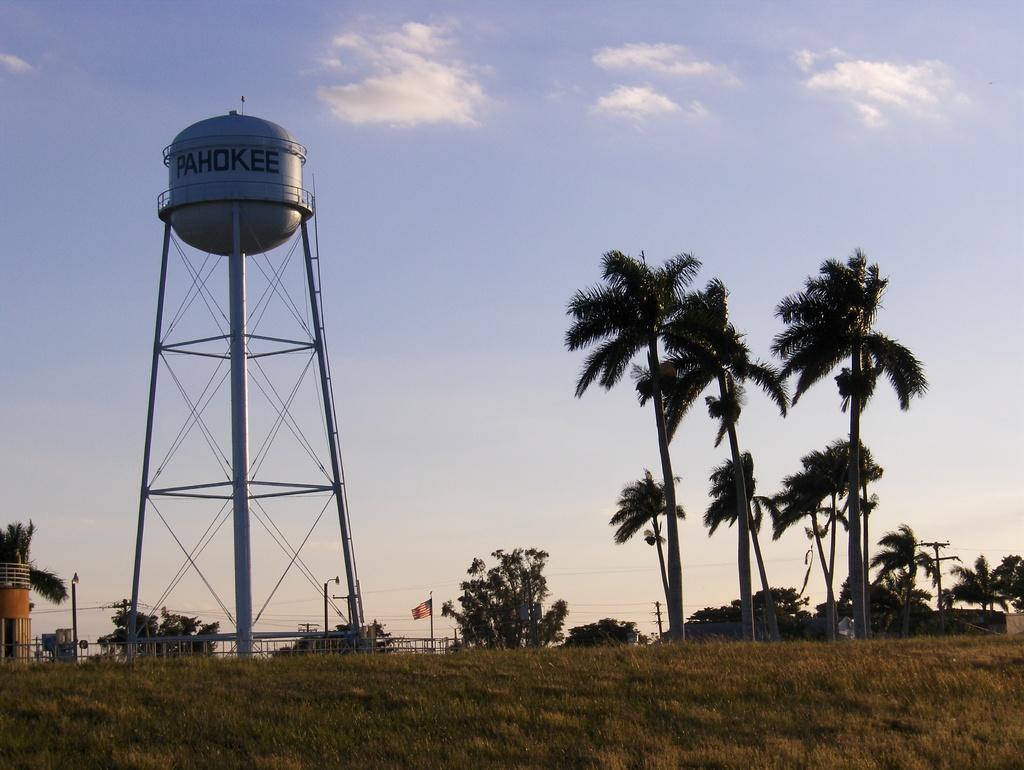Describe this image in one or two sentences. in this image we can see a tank placed on a stand. To the left side of the image we can see a building, a flag on a pole, group of trees,poles. In the background we can see the sky. 